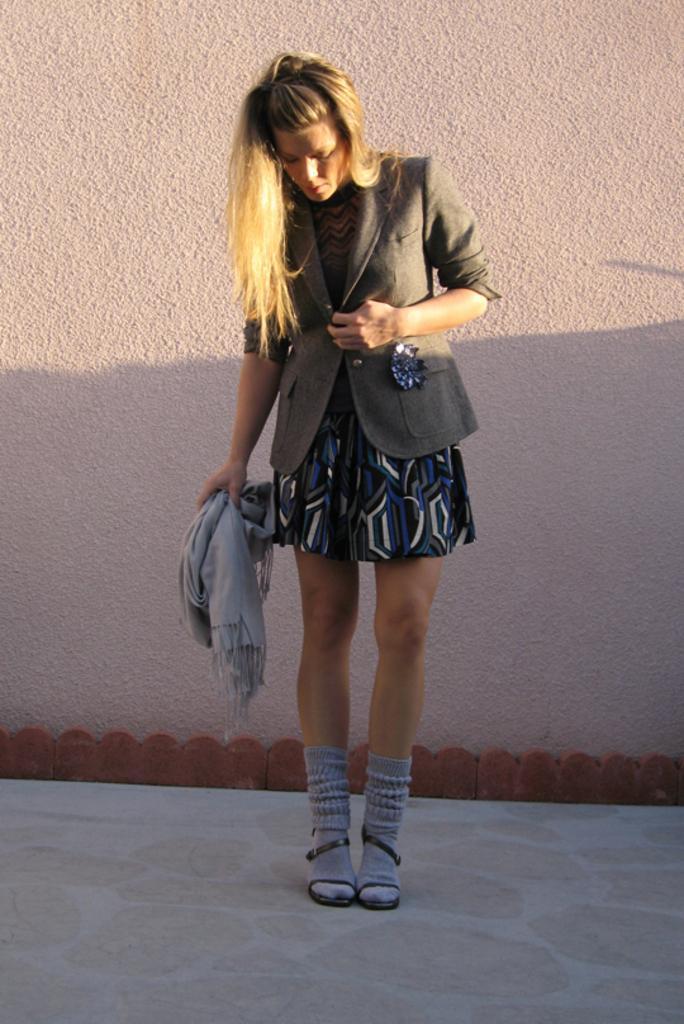In one or two sentences, can you explain what this image depicts? In this picture there is a woman who is wearing blazer, black dress and shoes. She is holding a scarf. She is standing near to the wall. 